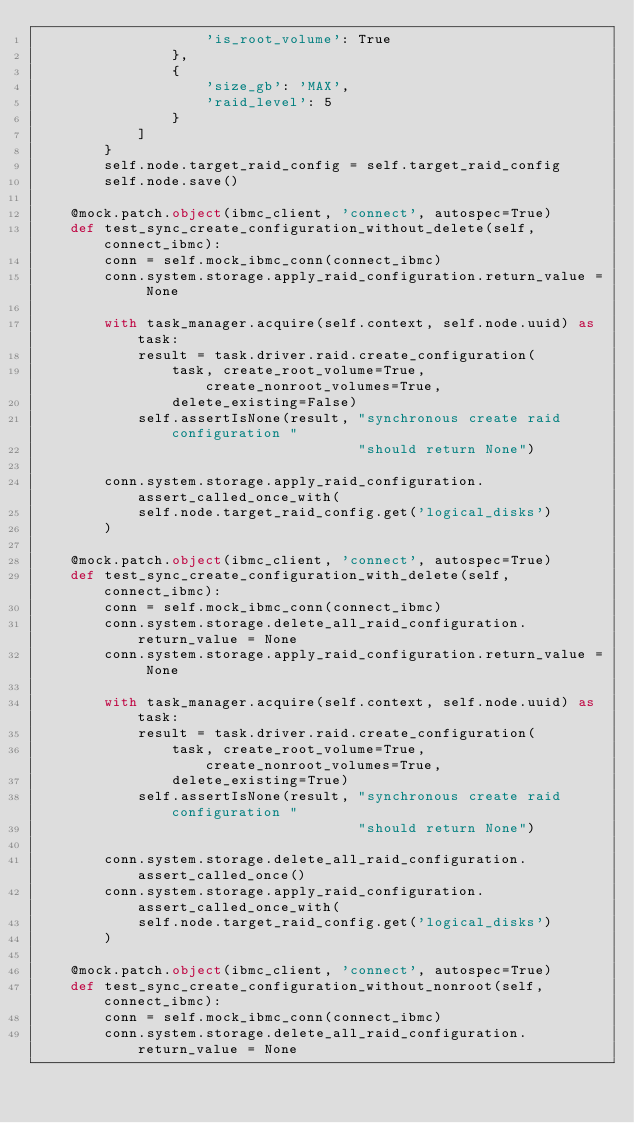Convert code to text. <code><loc_0><loc_0><loc_500><loc_500><_Python_>                    'is_root_volume': True
                },
                {
                    'size_gb': 'MAX',
                    'raid_level': 5
                }
            ]
        }
        self.node.target_raid_config = self.target_raid_config
        self.node.save()

    @mock.patch.object(ibmc_client, 'connect', autospec=True)
    def test_sync_create_configuration_without_delete(self, connect_ibmc):
        conn = self.mock_ibmc_conn(connect_ibmc)
        conn.system.storage.apply_raid_configuration.return_value = None

        with task_manager.acquire(self.context, self.node.uuid) as task:
            result = task.driver.raid.create_configuration(
                task, create_root_volume=True, create_nonroot_volumes=True,
                delete_existing=False)
            self.assertIsNone(result, "synchronous create raid configuration "
                                      "should return None")

        conn.system.storage.apply_raid_configuration.assert_called_once_with(
            self.node.target_raid_config.get('logical_disks')
        )

    @mock.patch.object(ibmc_client, 'connect', autospec=True)
    def test_sync_create_configuration_with_delete(self, connect_ibmc):
        conn = self.mock_ibmc_conn(connect_ibmc)
        conn.system.storage.delete_all_raid_configuration.return_value = None
        conn.system.storage.apply_raid_configuration.return_value = None

        with task_manager.acquire(self.context, self.node.uuid) as task:
            result = task.driver.raid.create_configuration(
                task, create_root_volume=True, create_nonroot_volumes=True,
                delete_existing=True)
            self.assertIsNone(result, "synchronous create raid configuration "
                                      "should return None")

        conn.system.storage.delete_all_raid_configuration.assert_called_once()
        conn.system.storage.apply_raid_configuration.assert_called_once_with(
            self.node.target_raid_config.get('logical_disks')
        )

    @mock.patch.object(ibmc_client, 'connect', autospec=True)
    def test_sync_create_configuration_without_nonroot(self, connect_ibmc):
        conn = self.mock_ibmc_conn(connect_ibmc)
        conn.system.storage.delete_all_raid_configuration.return_value = None</code> 